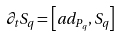<formula> <loc_0><loc_0><loc_500><loc_500>\partial _ { t } S _ { q } = \left [ a d _ { P _ { q } } , S _ { q } \right ]</formula> 